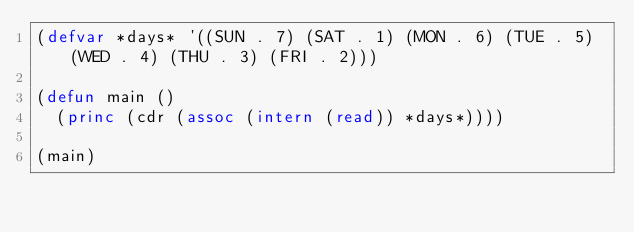<code> <loc_0><loc_0><loc_500><loc_500><_Lisp_>(defvar *days* '((SUN . 7) (SAT . 1) (MON . 6) (TUE . 5) (WED . 4) (THU . 3) (FRI . 2)))

(defun main ()
  (princ (cdr (assoc (intern (read)) *days*))))

(main)</code> 